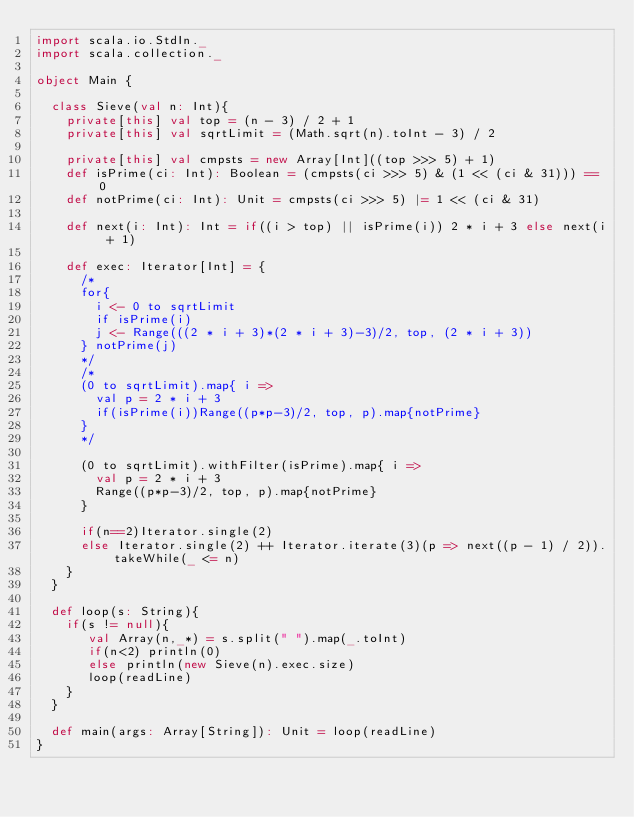Convert code to text. <code><loc_0><loc_0><loc_500><loc_500><_Scala_>import scala.io.StdIn._
import scala.collection._

object Main {

  class Sieve(val n: Int){
    private[this] val top = (n - 3) / 2 + 1
    private[this] val sqrtLimit = (Math.sqrt(n).toInt - 3) / 2

    private[this] val cmpsts = new Array[Int]((top >>> 5) + 1)
    def isPrime(ci: Int): Boolean = (cmpsts(ci >>> 5) & (1 << (ci & 31))) == 0
    def notPrime(ci: Int): Unit = cmpsts(ci >>> 5) |= 1 << (ci & 31)

    def next(i: Int): Int = if((i > top) || isPrime(i)) 2 * i + 3 else next(i + 1)

    def exec: Iterator[Int] = {
      /*
      for{
        i <- 0 to sqrtLimit
        if isPrime(i)
        j <- Range(((2 * i + 3)*(2 * i + 3)-3)/2, top, (2 * i + 3))
      } notPrime(j)
      */
      /*
      (0 to sqrtLimit).map{ i =>
        val p = 2 * i + 3
        if(isPrime(i))Range((p*p-3)/2, top, p).map{notPrime}
      }
      */

      (0 to sqrtLimit).withFilter(isPrime).map{ i =>
        val p = 2 * i + 3
        Range((p*p-3)/2, top, p).map{notPrime}
      }

      if(n==2)Iterator.single(2)
      else Iterator.single(2) ++ Iterator.iterate(3)(p => next((p - 1) / 2)).takeWhile(_ <= n)
    }
  }

  def loop(s: String){
    if(s != null){
       val Array(n,_*) = s.split(" ").map(_.toInt)
       if(n<2) println(0)
       else println(new Sieve(n).exec.size)
       loop(readLine)
    }
  }

  def main(args: Array[String]): Unit = loop(readLine)
}</code> 